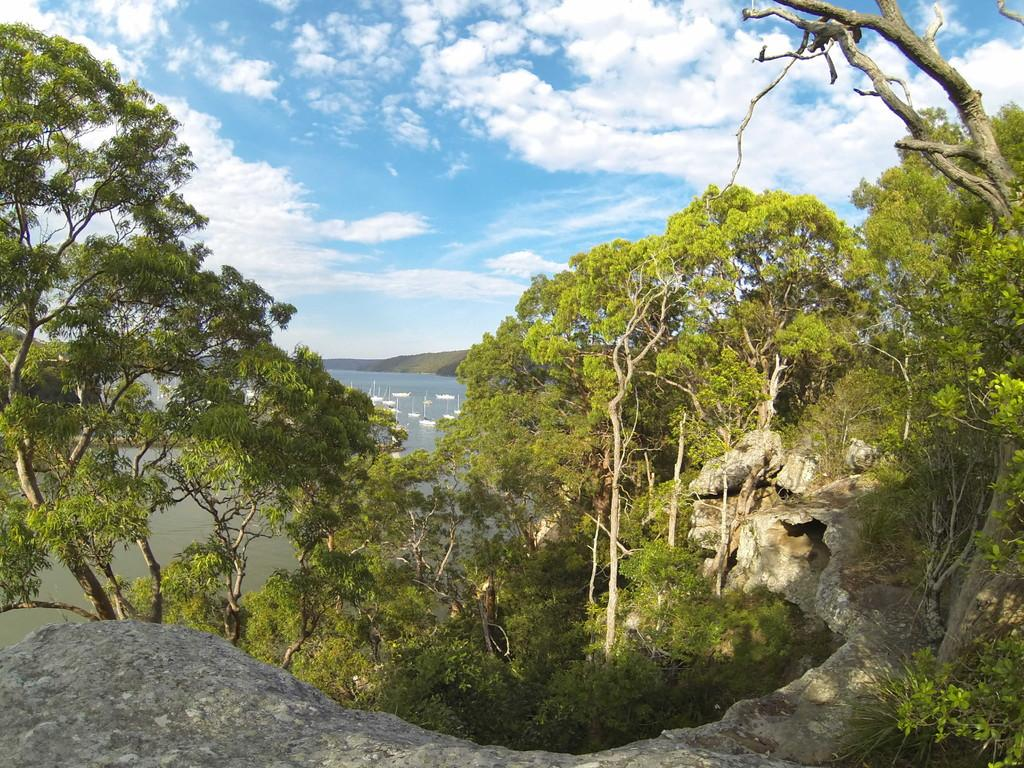What types of natural elements can be seen in the foreground of the image? There are trees, mountains, rocks, and grass in the foreground of the image. What is present in the water in the foreground of the image? There are fleets of boats in the water in the foreground of the image. What is the color of the sky in the background of the image? The sky is blue in the background of the image. Can you determine the time of day from the image? Yes, the image appears to be taken during the day. What type of plantation is visible in the image? There is no plantation present in the image. What year was the image taken? The provided facts do not include information about the year the image was taken. 